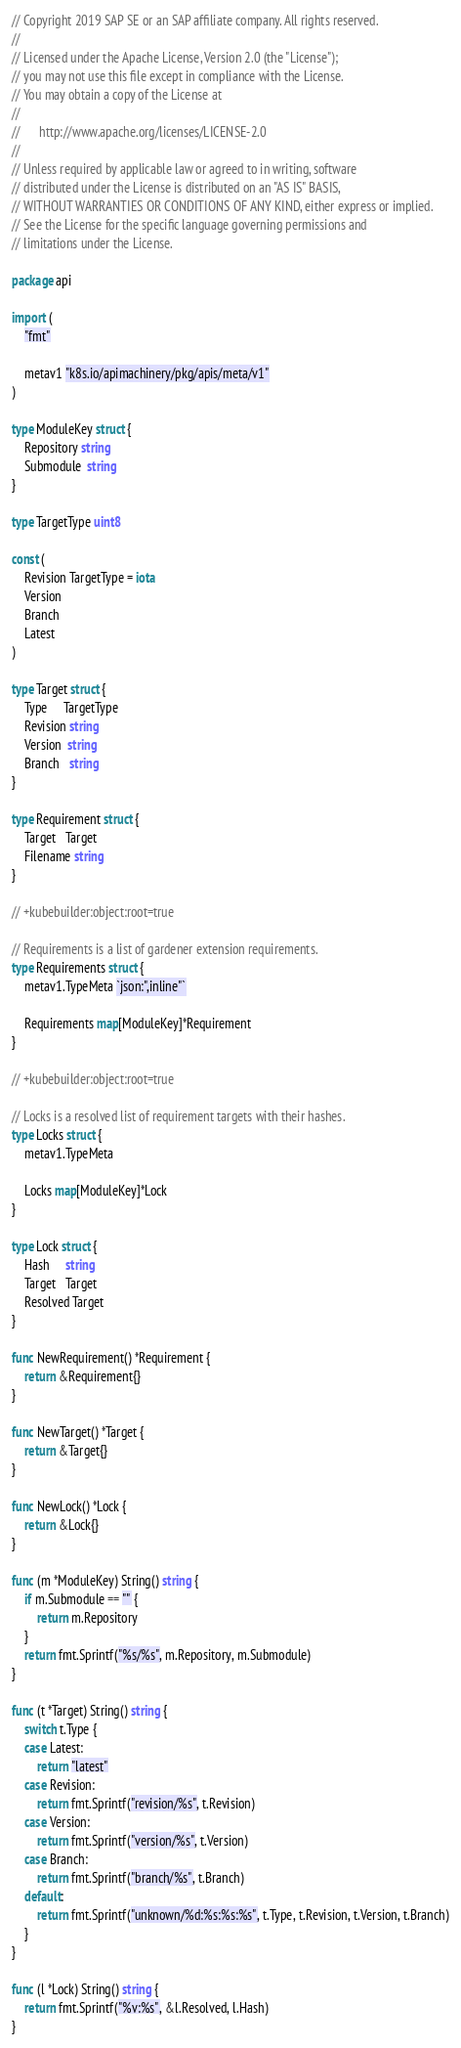Convert code to text. <code><loc_0><loc_0><loc_500><loc_500><_Go_>// Copyright 2019 SAP SE or an SAP affiliate company. All rights reserved.
//
// Licensed under the Apache License, Version 2.0 (the "License");
// you may not use this file except in compliance with the License.
// You may obtain a copy of the License at
//
//      http://www.apache.org/licenses/LICENSE-2.0
//
// Unless required by applicable law or agreed to in writing, software
// distributed under the License is distributed on an "AS IS" BASIS,
// WITHOUT WARRANTIES OR CONDITIONS OF ANY KIND, either express or implied.
// See the License for the specific language governing permissions and
// limitations under the License.

package api

import (
	"fmt"

	metav1 "k8s.io/apimachinery/pkg/apis/meta/v1"
)

type ModuleKey struct {
	Repository string
	Submodule  string
}

type TargetType uint8

const (
	Revision TargetType = iota
	Version
	Branch
	Latest
)

type Target struct {
	Type     TargetType
	Revision string
	Version  string
	Branch   string
}

type Requirement struct {
	Target   Target
	Filename string
}

// +kubebuilder:object:root=true

// Requirements is a list of gardener extension requirements.
type Requirements struct {
	metav1.TypeMeta `json:",inline"`

	Requirements map[ModuleKey]*Requirement
}

// +kubebuilder:object:root=true

// Locks is a resolved list of requirement targets with their hashes.
type Locks struct {
	metav1.TypeMeta

	Locks map[ModuleKey]*Lock
}

type Lock struct {
	Hash     string
	Target   Target
	Resolved Target
}

func NewRequirement() *Requirement {
	return &Requirement{}
}

func NewTarget() *Target {
	return &Target{}
}

func NewLock() *Lock {
	return &Lock{}
}

func (m *ModuleKey) String() string {
	if m.Submodule == "" {
		return m.Repository
	}
	return fmt.Sprintf("%s/%s", m.Repository, m.Submodule)
}

func (t *Target) String() string {
	switch t.Type {
	case Latest:
		return "latest"
	case Revision:
		return fmt.Sprintf("revision/%s", t.Revision)
	case Version:
		return fmt.Sprintf("version/%s", t.Version)
	case Branch:
		return fmt.Sprintf("branch/%s", t.Branch)
	default:
		return fmt.Sprintf("unknown/%d:%s:%s:%s", t.Type, t.Revision, t.Version, t.Branch)
	}
}

func (l *Lock) String() string {
	return fmt.Sprintf("%v:%s", &l.Resolved, l.Hash)
}
</code> 